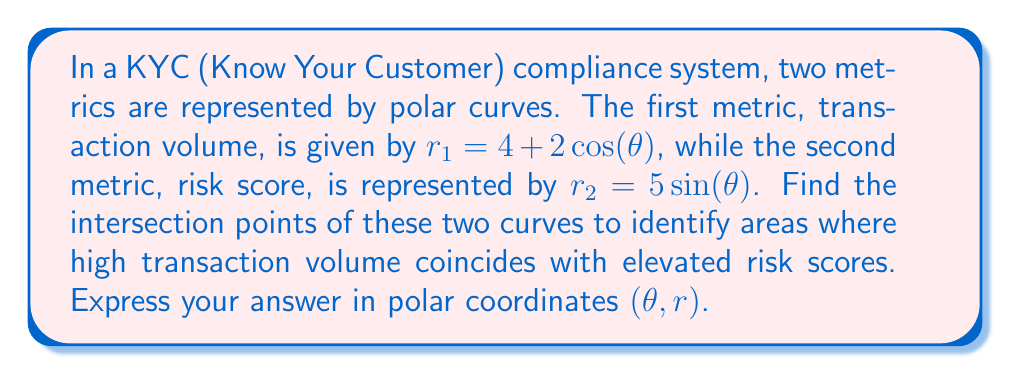Provide a solution to this math problem. To find the intersection points of the two polar curves, we need to solve the equation:

$$ 4 + 2\cos(\theta) = 5\sin(\theta) $$

1) First, let's isolate the trigonometric functions on one side:

   $$ 2\cos(\theta) - 5\sin(\theta) = -4 $$

2) We can use the substitution method. Let $R = \sqrt{2^2 + 5^2} = \sqrt{29}$ and $\tan(\alpha) = \frac{5}{2}$. Then:

   $$ R\cos(\theta + \alpha) = -4 $$

3) Solving for $\theta + \alpha$:

   $$ \theta + \alpha = \arccos\left(-\frac{4}{\sqrt{29}}\right) \text{ or } \theta + \alpha = -\arccos\left(-\frac{4}{\sqrt{29}}\right) $$

4) Now, we can find $\alpha$:

   $$ \alpha = \arctan\left(\frac{5}{2}\right) \approx 1.1903 \text{ radians} $$

5) Solving for $\theta$:

   $$ \theta = \arccos\left(-\frac{4}{\sqrt{29}}\right) - 1.1903 \approx 2.4965 \text{ radians} $$
   $$ \theta = -\arccos\left(-\frac{4}{\sqrt{29}}\right) - 1.1903 \approx -3.7868 \text{ radians} $$

6) To find $r$, we can substitute either $\theta$ value into either of the original equations. Let's use $r_1 = 4 + 2\cos(\theta)$:

   For $\theta \approx 2.4965$:
   $$ r \approx 4 + 2\cos(2.4965) \approx 2.6180 $$

   For $\theta \approx -3.7868$:
   $$ r \approx 4 + 2\cos(-3.7868) \approx 2.6180 $$

Therefore, the intersection points are approximately $(2.4965, 2.6180)$ and $(-3.7868, 2.6180)$ in polar coordinates $(\theta, r)$.
Answer: The intersection points are approximately $(2.4965, 2.6180)$ and $(-3.7868, 2.6180)$ in polar coordinates $(\theta, r)$. 